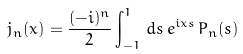Convert formula to latex. <formula><loc_0><loc_0><loc_500><loc_500>j _ { n } ( x ) = \frac { ( - i ) ^ { n } } { 2 } \int _ { - 1 } ^ { 1 } \, d s \, e ^ { i x s } \, P _ { n } ( s )</formula> 